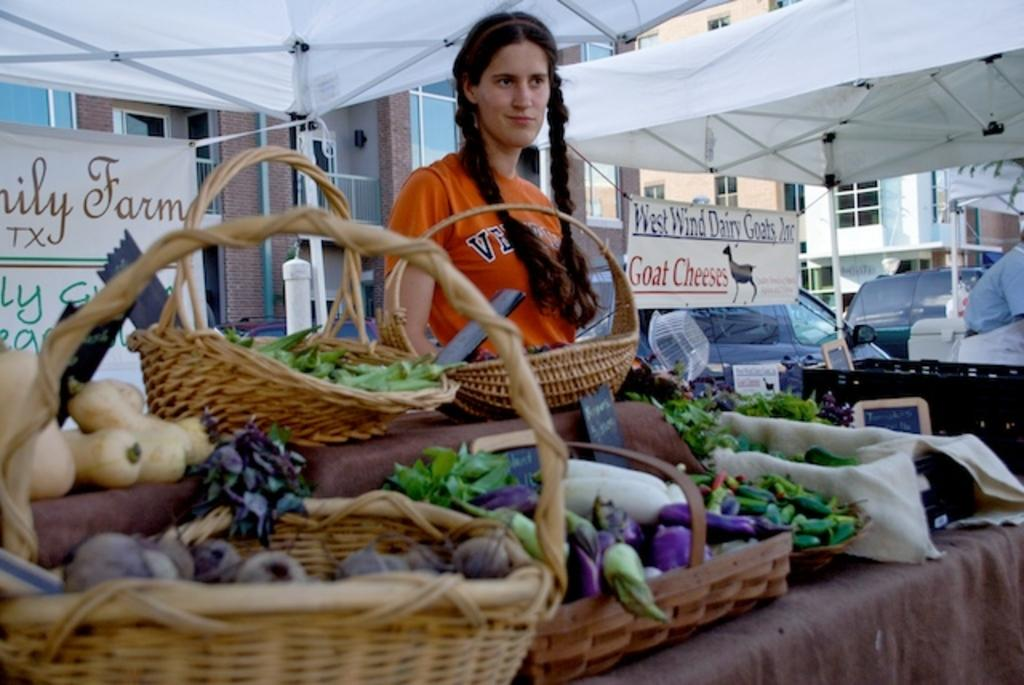Who or what can be seen in the image? There are people in the image. What types of food items are visible in the image? There are different types of vegetables in the image. What kind of structures are present in the image? There are buildings in the image. What additional items can be seen in the image? There are banners and vehicles in the image. What else might be present in the image? There are boards in the image. What type of agreement can be seen in the image? There is no agreement visible in the image. How does the acoustics of the scene affect the people in the image? The provided facts do not mention anything about the acoustics of the scene, so we cannot determine how it affects the people in the image. 